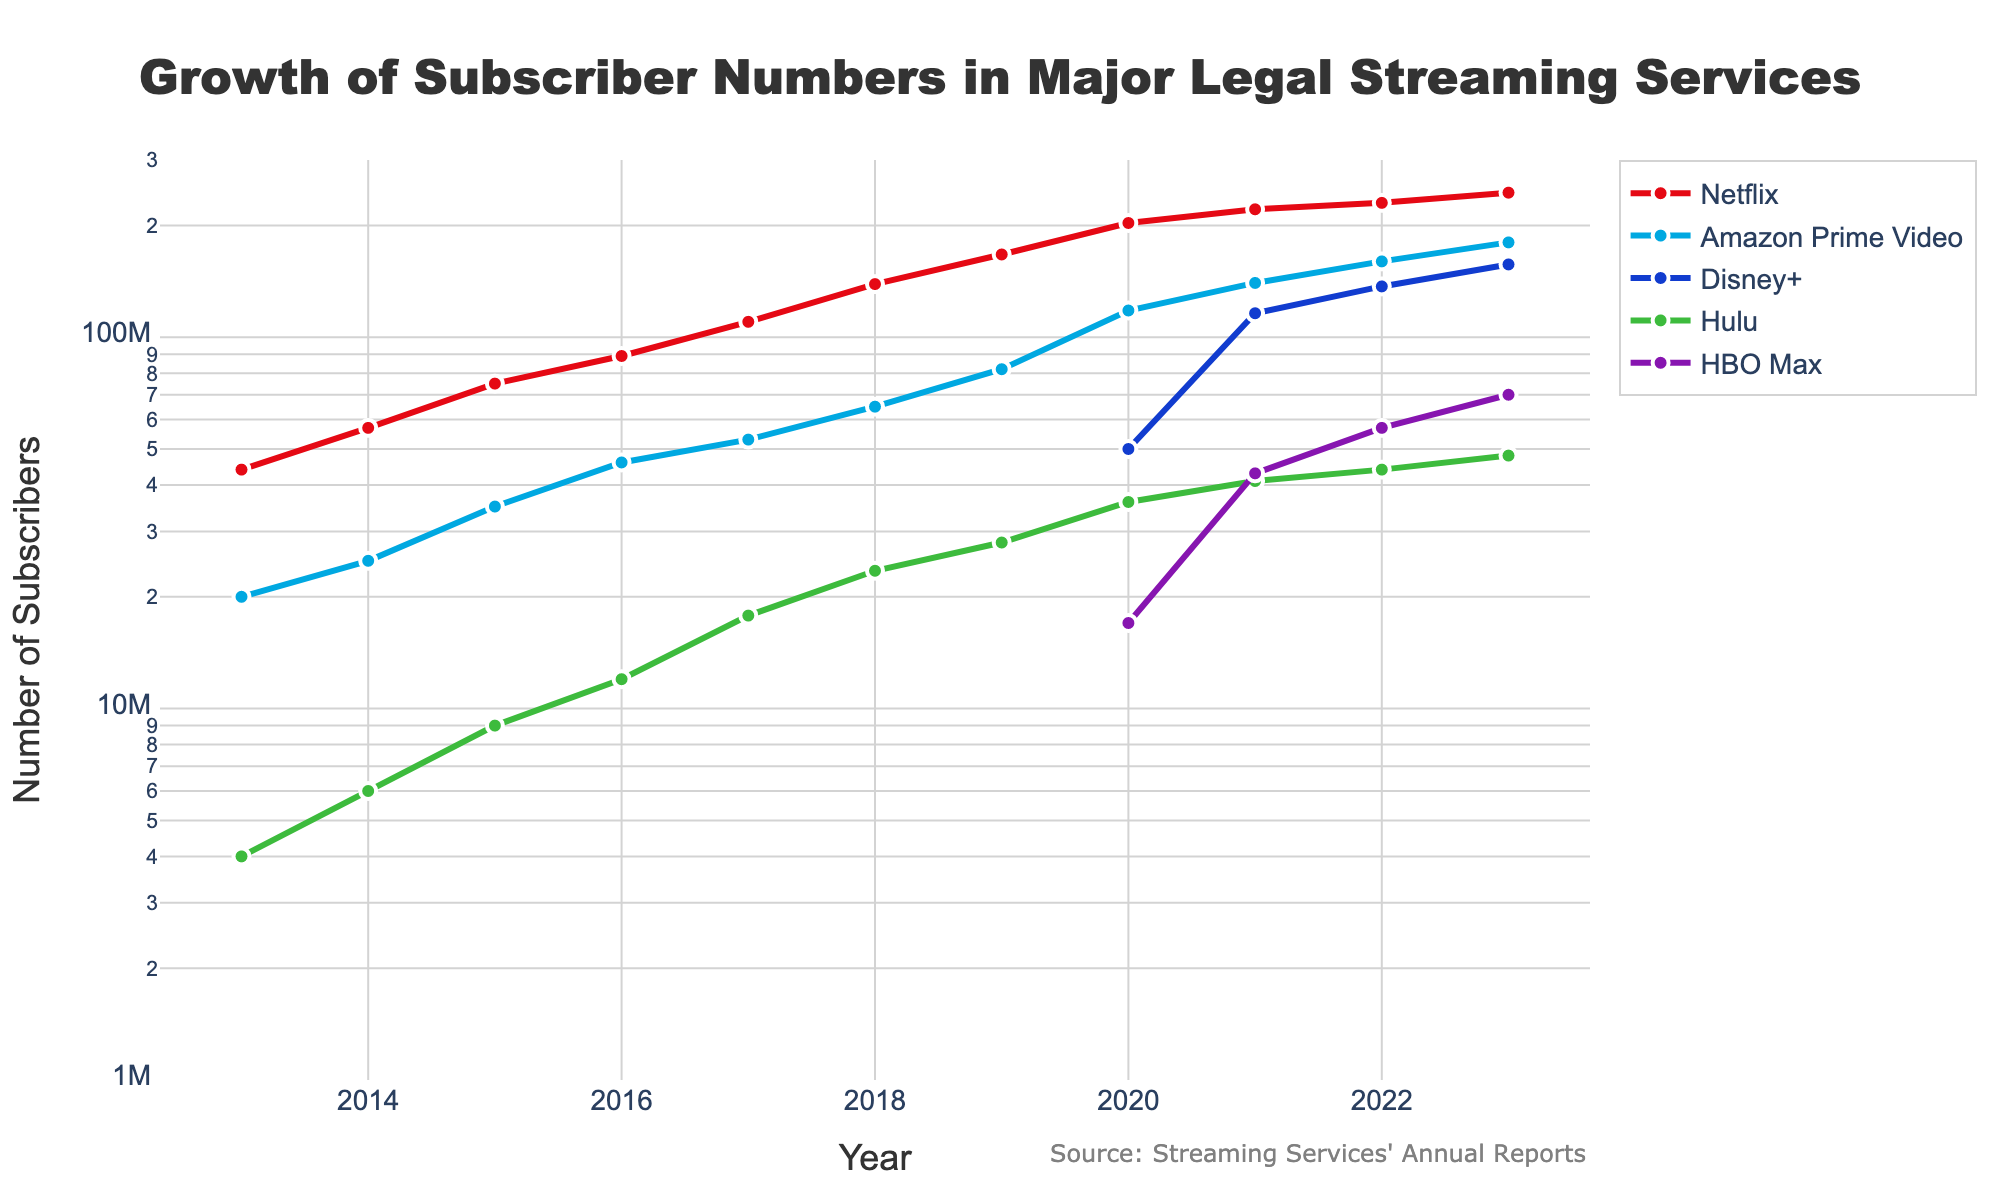What is the title of the plot? The title of the plot is located at the top and is described in large, bold font. It reads: "Growth of Subscriber Numbers in Major Legal Streaming Services."
Answer: Growth of Subscriber Numbers in Major Legal Streaming Services In which year did Disney+ start gaining subscribers? The figure shows that Disney+ has NA (Not Applicable) for years before 2020. It starts showing subscriber numbers from 2020 onwards.
Answer: 2020 Which streaming service had the highest number of subscribers in 2023? By looking at the subscribers' values on the y-axis for the year 2023, the highest value is approximately 245 million for Netflix.
Answer: Netflix How many streaming services had subscriber numbers above 100 million in 2021? From the y-axis value for the year 2021, Netflix (221 million), Amazon Prime Video (140 million), and Disney+ (116 million) all had subscriber numbers above 100 million.
Answer: 3 Which streaming service showed the largest increase in subscribers from 2019 to 2020? Comparing the difference in subscriber values between 2019 and 2020: 
    - Netflix: 203M - 167M = 36M
    - Amazon Prime Video: 118M - 82M = 36M
    - Disney+: 50M (New in 2020)
    - Hulu: 36M - 28M = 8M
    - HBO Max: 17M (New in 2020)
Amazon Prime Video and Netflix both show an increase of 36 million.
Answer: Netflix and Amazon Prime Video In 2018, did Hulu have more subscribers than HBO Max in 2022? In 2018, Hulu had 23.5 million subscribers. In 2022, HBO Max had 57 million subscribers. 57 million is greater than 23.5 million.
Answer: No Which streaming service had no subscribers data available until 2020? The figure shows NA (Not Applicable) for Disney+ and HBO Max until 2020. Thus, they both have no subscriber data available until 2020.
Answer: Disney+ and HBO Max By how many million did Hulu’s subscribers increase from 2017 to 2023? In 2017, Hulu had 17.8 million subscribers, and in 2023, it had 48 million subscribers. The increase is 48M - 17.8M = 30.2M.
Answer: 30.2 million 